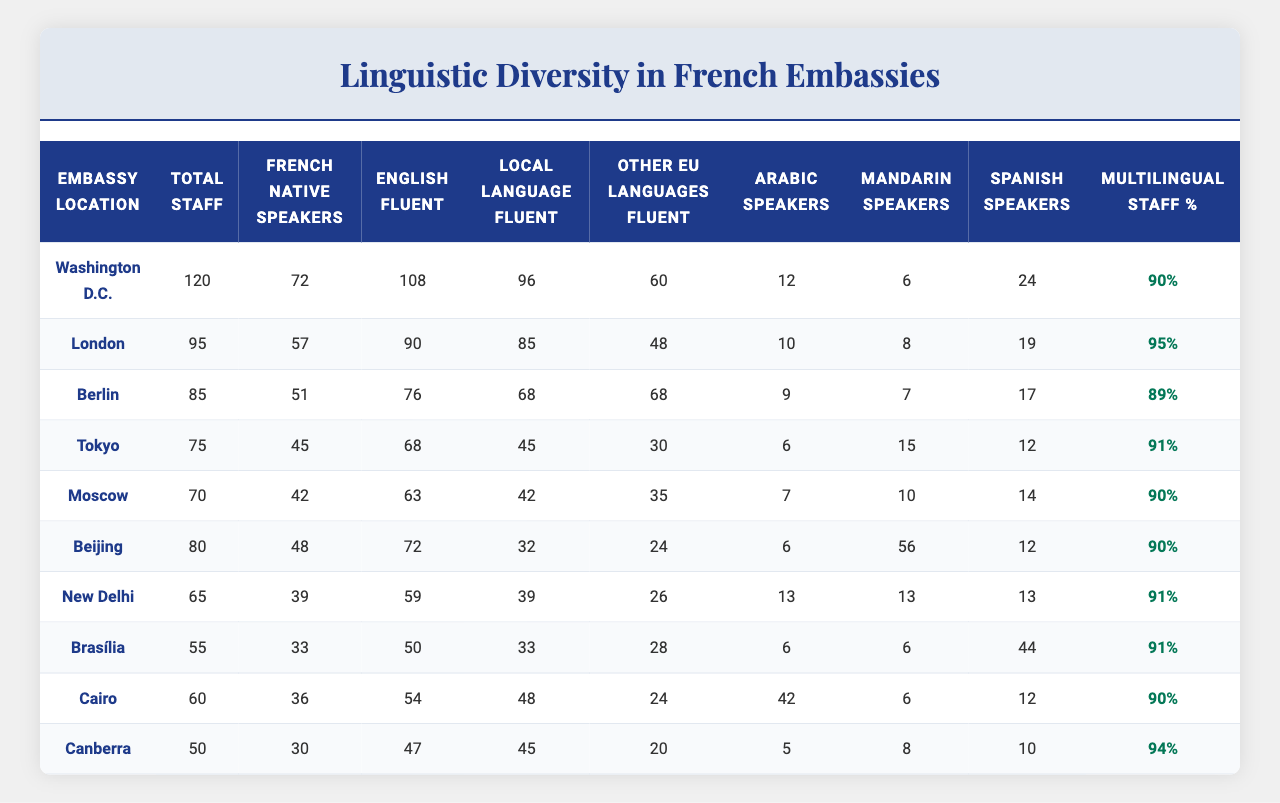What is the total number of staff in the Berlin embassy? The table indicates that the "Total Staff" in the Berlin embassy is 85 as listed under the "Total Staff" column.
Answer: 85 How many French native speakers are there in the Moscow embassy? According to the table, the number of "French Native Speakers" in the Moscow embassy is 42, as shown in the corresponding column.
Answer: 42 Which embassy has the highest number of Arabic speakers? The table shows that the Cairo embassy has the highest number of Arabic speakers, with a total of 42 listed in the "Arabic Speakers" column.
Answer: Cairo What is the percentage of multilingual staff in the New Delhi embassy? The "Multilingual Staff Percentage" for the New Delhi embassy is 91% according to the table.
Answer: 91% What is the difference between the total staff count in Washington D.C. and Canberra? The total staff in Washington D.C. is 120, and in Canberra, it is 50. The difference is 120 - 50 = 70.
Answer: 70 How many staff members in Beijing are fluent in English? In the table, it shows that 72 staff members in the Beijing embassy are fluent in English.
Answer: 72 Which embassy has the lowest number of Spanish speakers? By examining the "Spanish Speakers" column, it is evident that the Canberra embassy has the lowest count at 10.
Answer: Canberra What is the average number of French native speakers across all embassies? To find the average, sum the French native speakers (72 + 57 + 51 + 45 + 42 + 48 + 39 + 33 + 36 + 30 = 453) and divide by the number of embassies (10). The average is 453 / 10 = 45.3.
Answer: 45.3 Is there a higher number of Mandarin speakers or Arabic speakers in London? In London, the table shows 8 Mandarin speakers and 10 Arabic speakers. Since 10 is greater than 8, there are more Arabic speakers.
Answer: Yes, more Arabic speakers What proportion of staff in Brasília are fluent in other EU languages? In Brasília, there are 55 total staff members, and 28 of them are fluent in other EU languages. The proportion is 28 / 55, which simplifies to approximately 50.9%.
Answer: 50.9% 